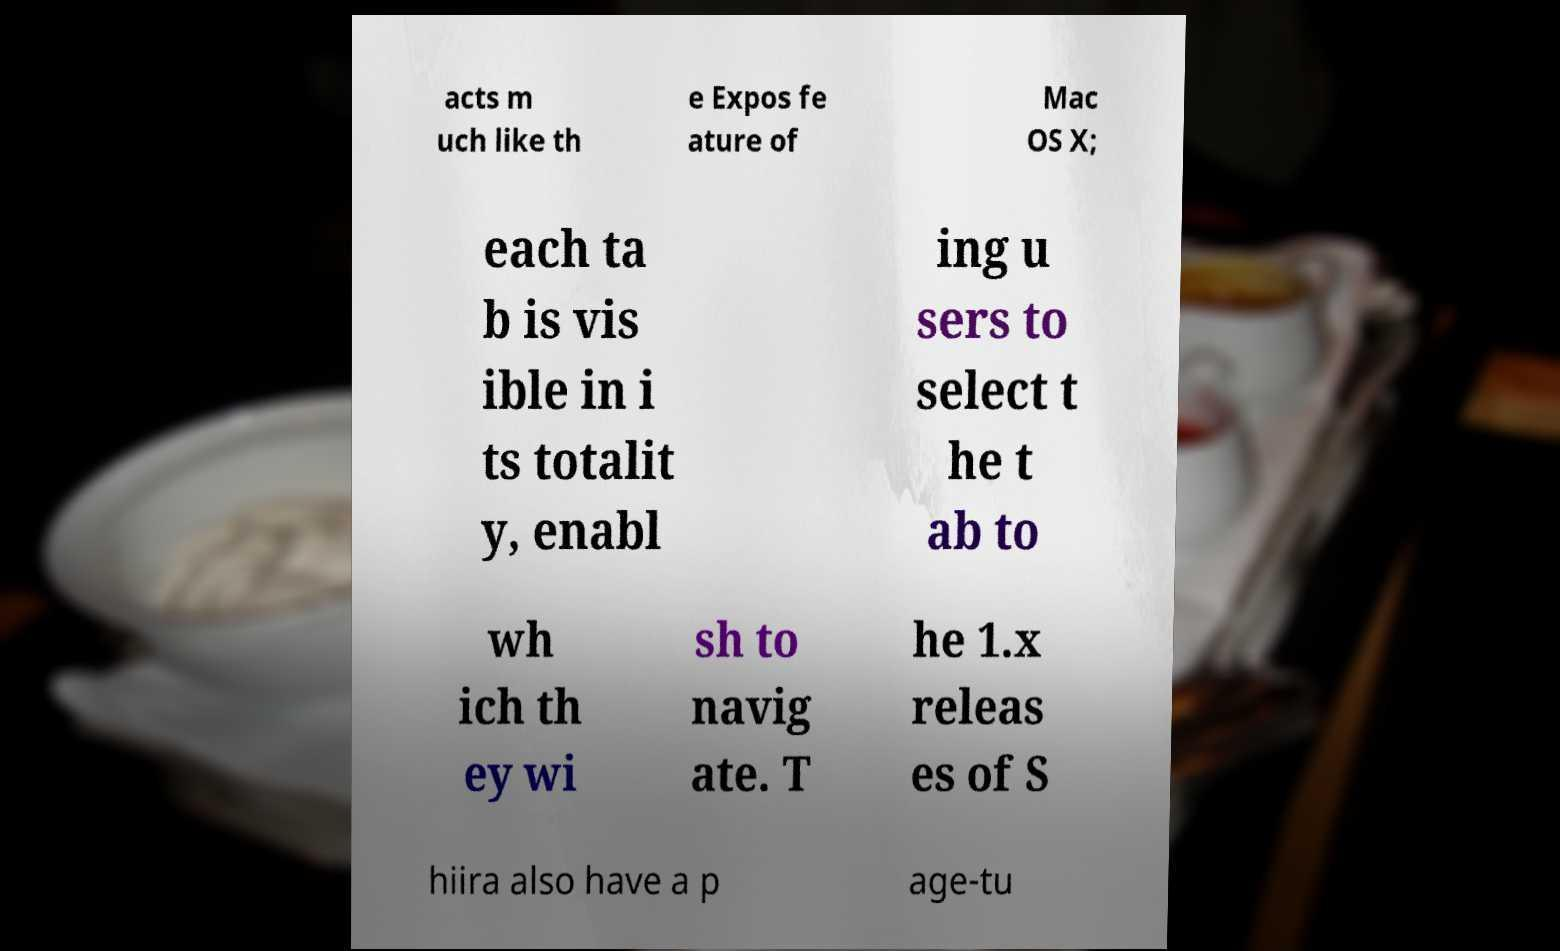Please identify and transcribe the text found in this image. acts m uch like th e Expos fe ature of Mac OS X; each ta b is vis ible in i ts totalit y, enabl ing u sers to select t he t ab to wh ich th ey wi sh to navig ate. T he 1.x releas es of S hiira also have a p age-tu 